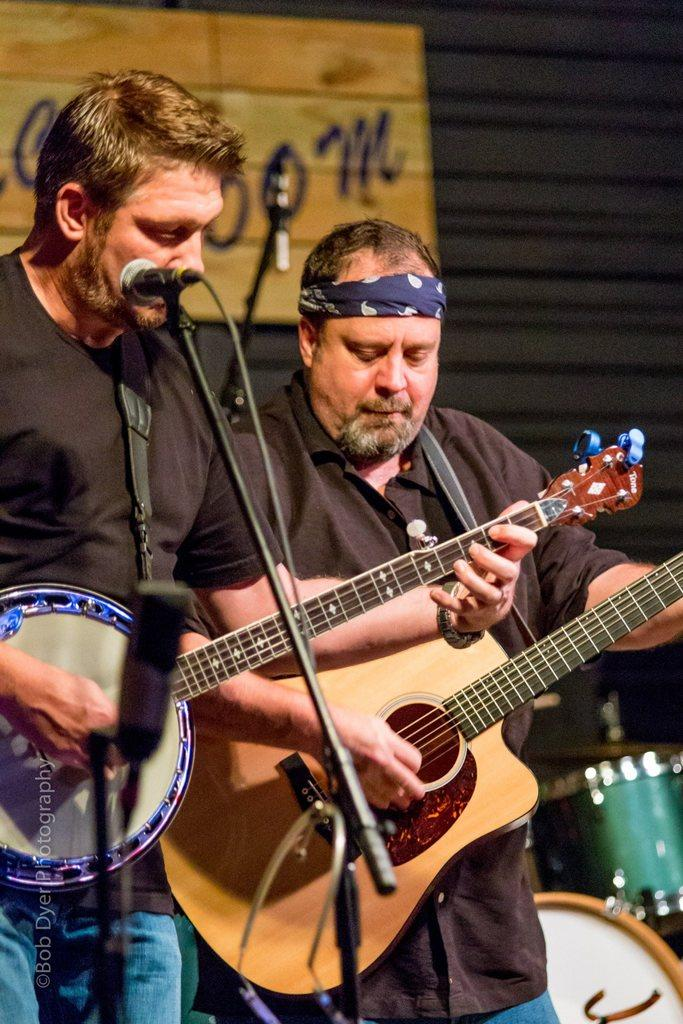How many people are in the image? There are two men in the image. What are the men doing in the image? The men are holding guitars and playing them, as well as singing into a microphone. What can be seen in the background of the image? There are drums, a wall, and a banner in the background of the image. What type of hook is the man using to catch fish in the image? There is no hook or fishing activity present in the image; the men are playing guitars and singing. 